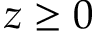Convert formula to latex. <formula><loc_0><loc_0><loc_500><loc_500>z \geq 0</formula> 